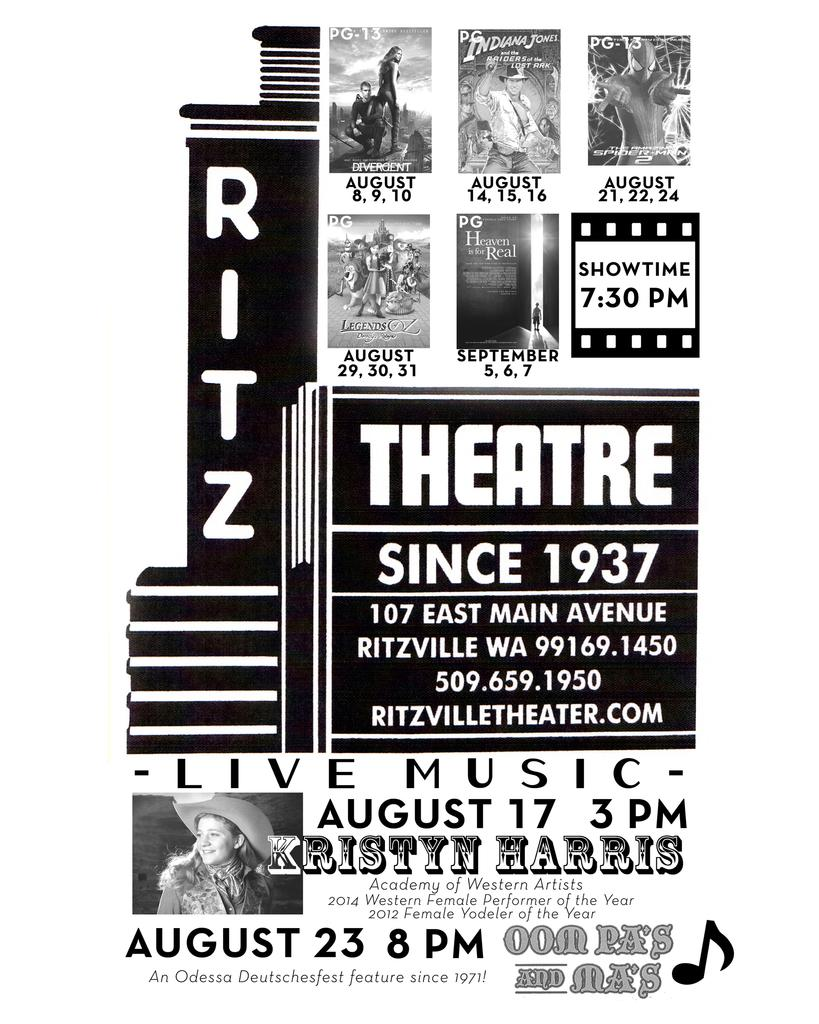<image>
Render a clear and concise summary of the photo. A poster for live music at the Ritz theater. 